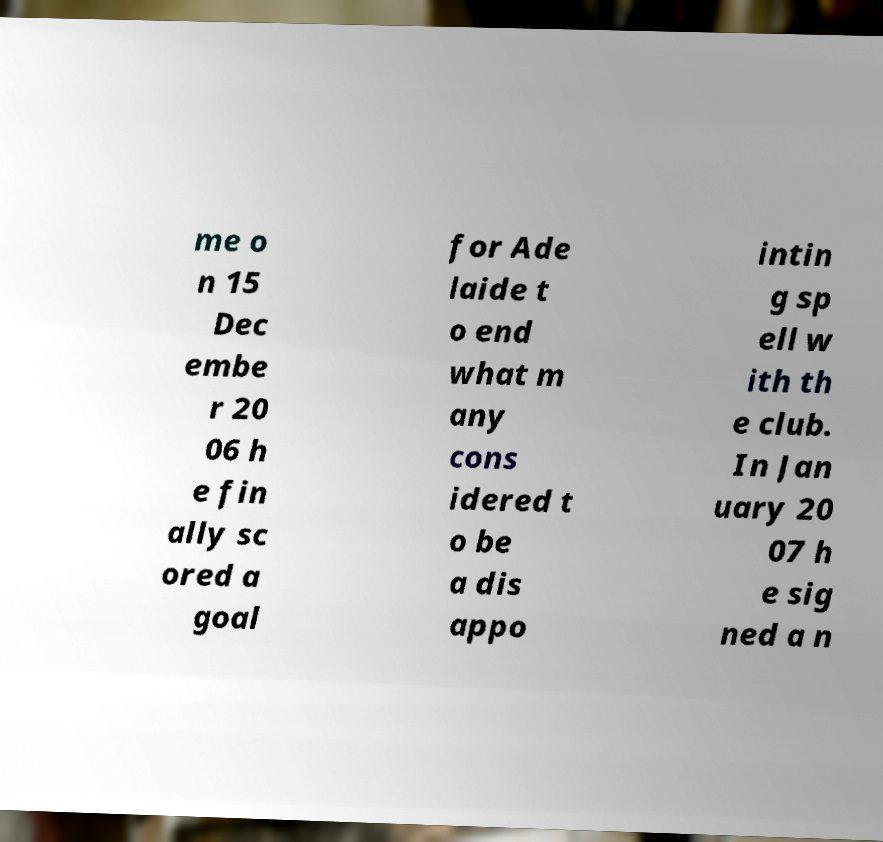Can you accurately transcribe the text from the provided image for me? me o n 15 Dec embe r 20 06 h e fin ally sc ored a goal for Ade laide t o end what m any cons idered t o be a dis appo intin g sp ell w ith th e club. In Jan uary 20 07 h e sig ned a n 